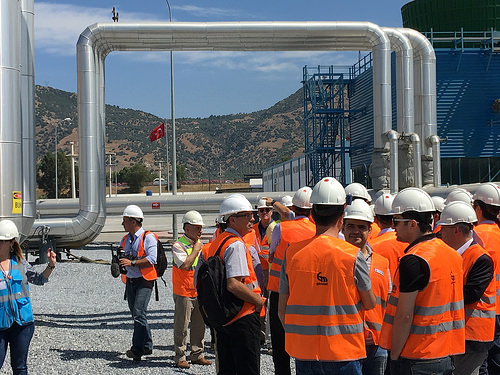<image>
Is the man to the left of the man? No. The man is not to the left of the man. From this viewpoint, they have a different horizontal relationship. 